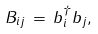<formula> <loc_0><loc_0><loc_500><loc_500>B _ { i j } \, = \, b ^ { \dagger } _ { i } b _ { j } ,</formula> 